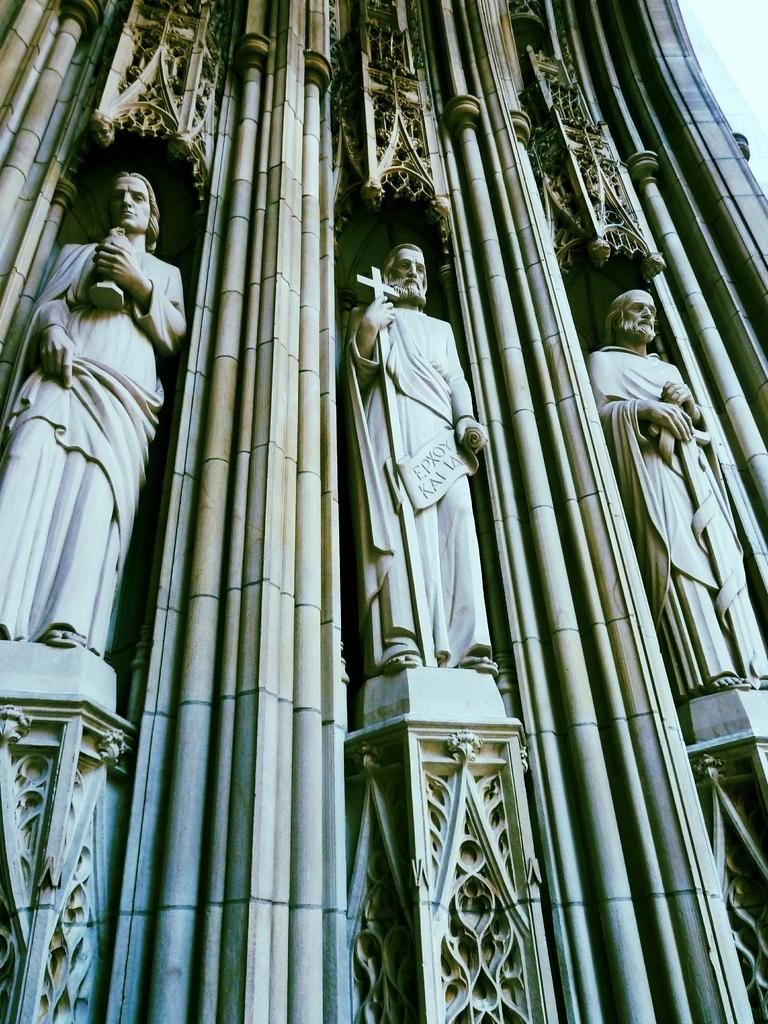What can be seen in the image? There are statues in the image. Can you describe the statues in more detail? Unfortunately, the provided facts do not give any additional details about the statues. Are there any other objects or elements in the image besides the statues? The given facts do not mention any other objects or elements in the image. What is the weight of the seashore in the image? There is no seashore present in the image, so it is not possible to determine its weight. 